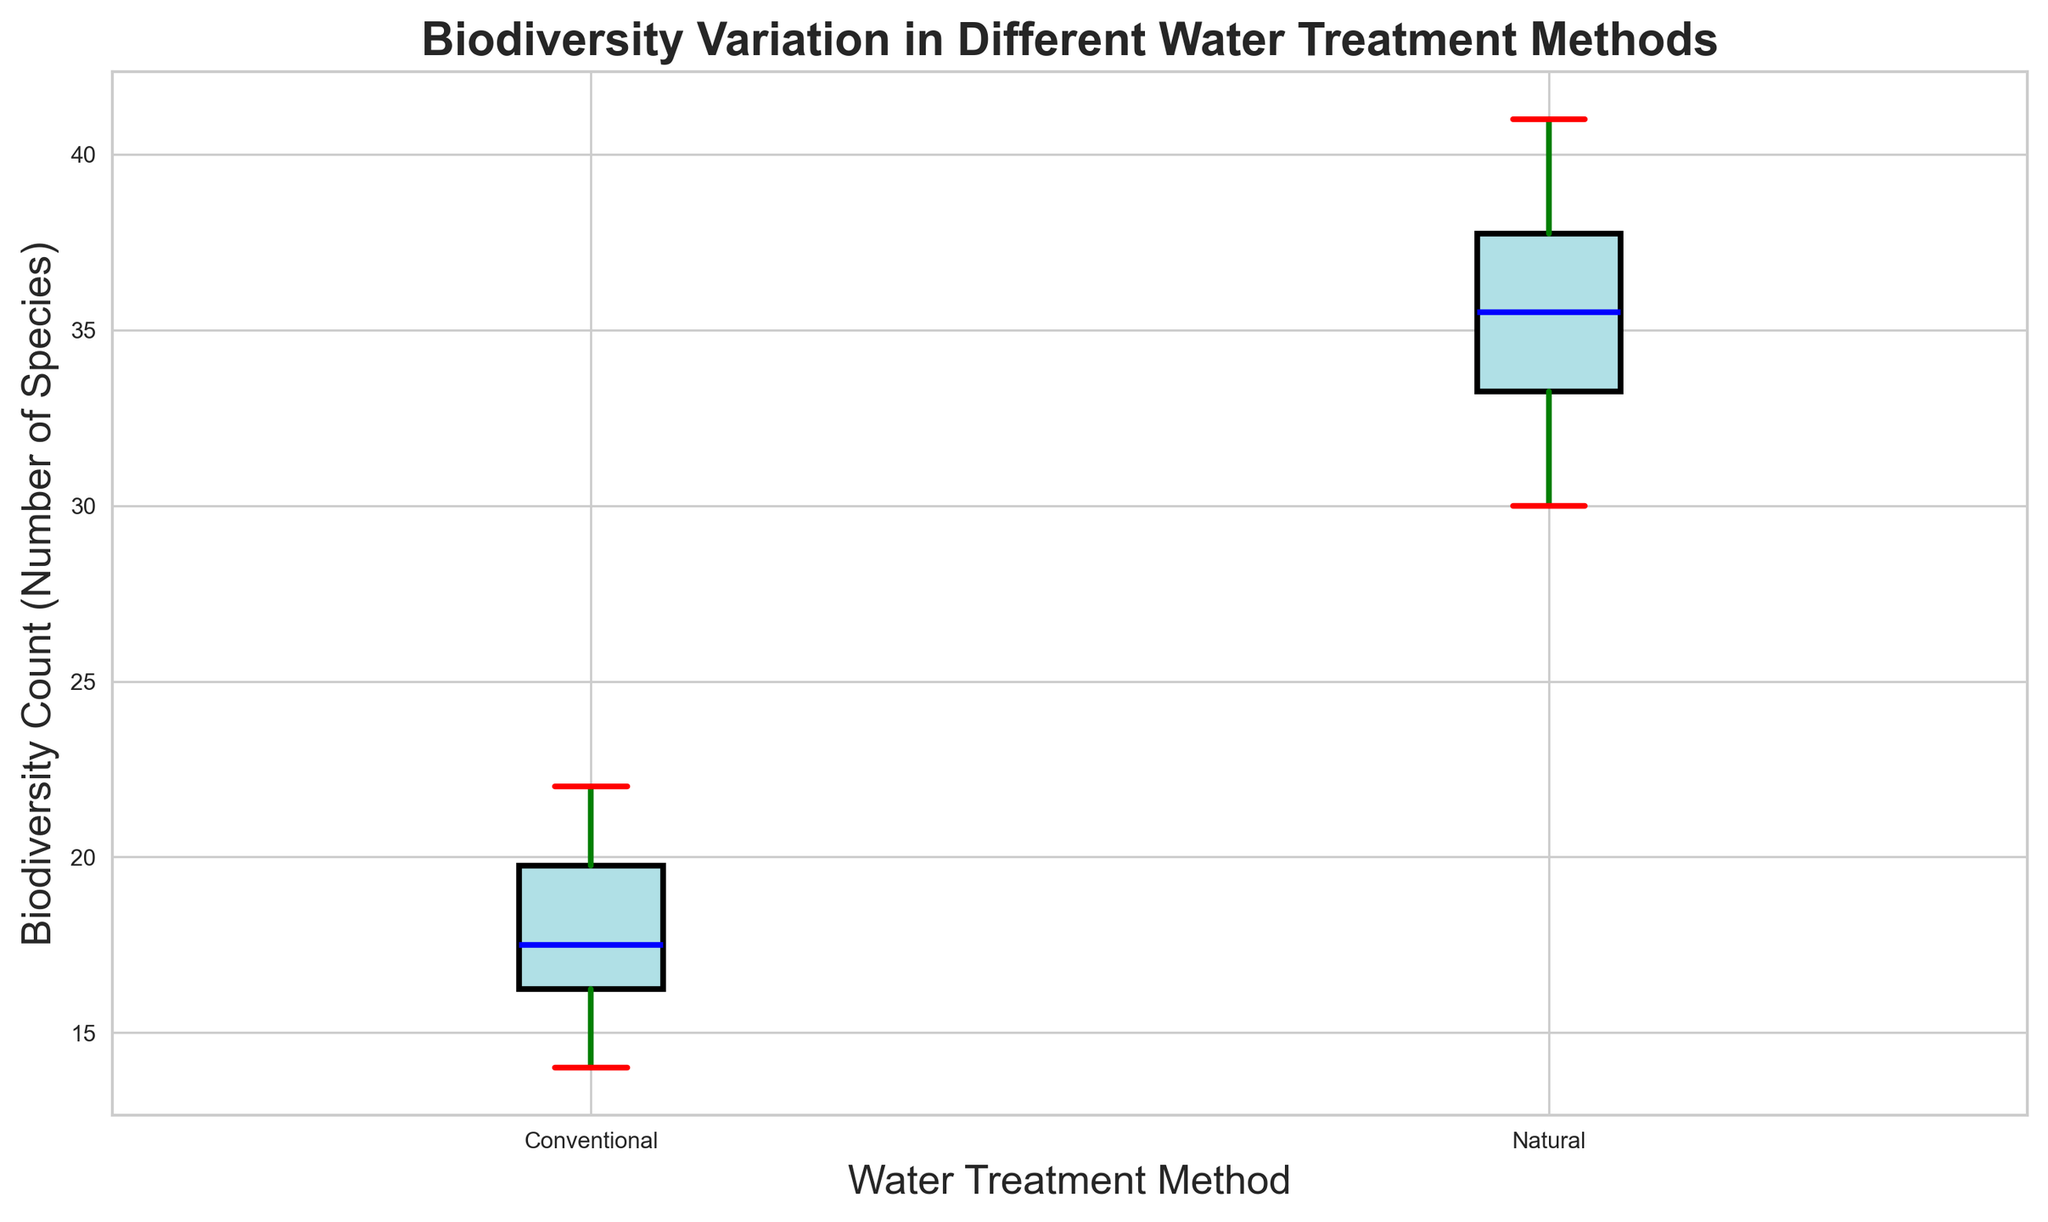What is the median biodiversity count for ecosystems using conventional water treatment methods? Locate the median line inside the box representing conventional water treatment methods. The median for the conventional method is about halfway up the box.
Answer: 17 What is the range of biodiversity counts for ecosystems using natural water treatment methods? Observe the distance between the lower whisker and the upper whisker of the box plot for natural water treatment methods. The smallest value is 30, and the largest value is 41. Subtract the smallest value from the largest value (41 - 30).
Answer: 11 Which water treatment method shows a higher median biodiversity count? Compare the median lines of both box plots. The median line for natural methods is higher than the median line for conventional methods.
Answer: Natural What are the lower and upper quartiles for biodiversity counts in ecosystems using conventional water treatment methods? Focus on the boundaries of the box representing the conventional treatment method. The lower quartile (Q1) is the bottom of the box, and the upper quartile (Q3) is the top of the box.
Answer: Q1: 15, Q3: 20 Which water treatment method shows more variability in biodiversity counts? Evaluate the length of the boxes (interquartile range, IQR) and the spread of the whiskers in both box plots. The box and whiskers for the natural method are longer, indicating higher variability.
Answer: Natural What is the interquartile range (IQR) of biodiversity counts for ecosystems using natural water treatment methods? The IQR is the difference between the upper quartile (Q3) and the lower quartile (Q1). For the natural method, estimate Q3 and Q1 from the box plot. Q1 is approximately 33, and Q3 is approximately 37. Subtract Q1 from Q3 (37 - 33).
Answer: 4 What are the minimum and maximum biodiversity counts for the conventional method? Look for the ends of the whiskers in the conventional box plot. The whiskers' endpoints represent the minimum and maximum values.
Answer: Min: 14, Max: 22 Are there any outliers in either method? Check for any points outside the whiskers for both box plots. There are no individual points marked outside the whiskers in either box plot, so there are no outliers.
Answer: No How much greater is the maximum biodiversity count for the natural method compared to the conventional method? Identify the maximum values for both methods and subtract the conventional method's maximum from the natural method's maximum (41 - 22).
Answer: 19 